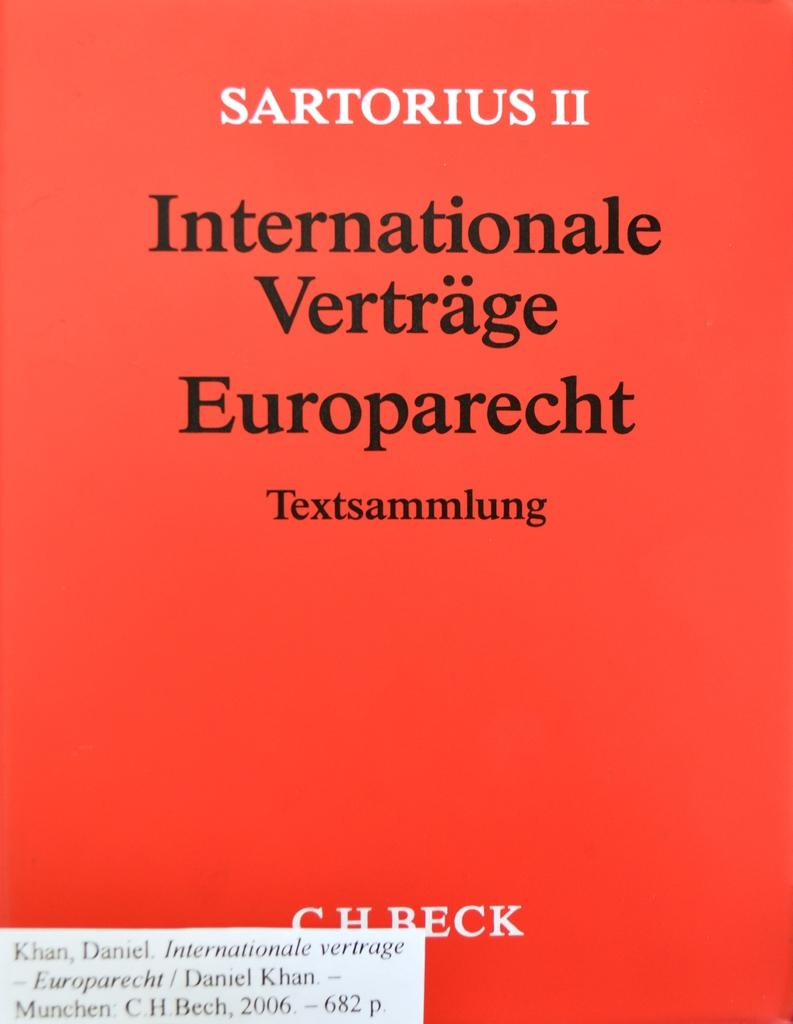<image>
Create a compact narrative representing the image presented. a book with the name sartorious on it 